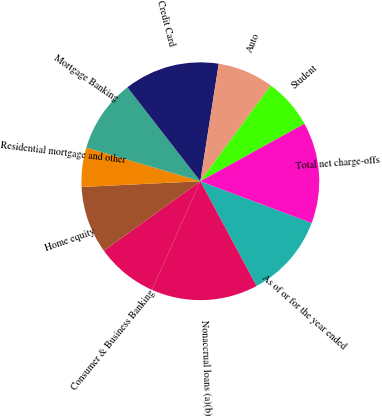<chart> <loc_0><loc_0><loc_500><loc_500><pie_chart><fcel>As of or for the year ended<fcel>Nonaccrual loans (a)(b)<fcel>Consumer & Business Banking<fcel>Home equity<fcel>Residential mortgage and other<fcel>Mortgage Banking<fcel>Credit Card<fcel>Auto<fcel>Student<fcel>Total net charge-offs<nl><fcel>11.45%<fcel>14.5%<fcel>8.4%<fcel>9.16%<fcel>5.34%<fcel>9.92%<fcel>12.98%<fcel>7.63%<fcel>6.87%<fcel>13.74%<nl></chart> 